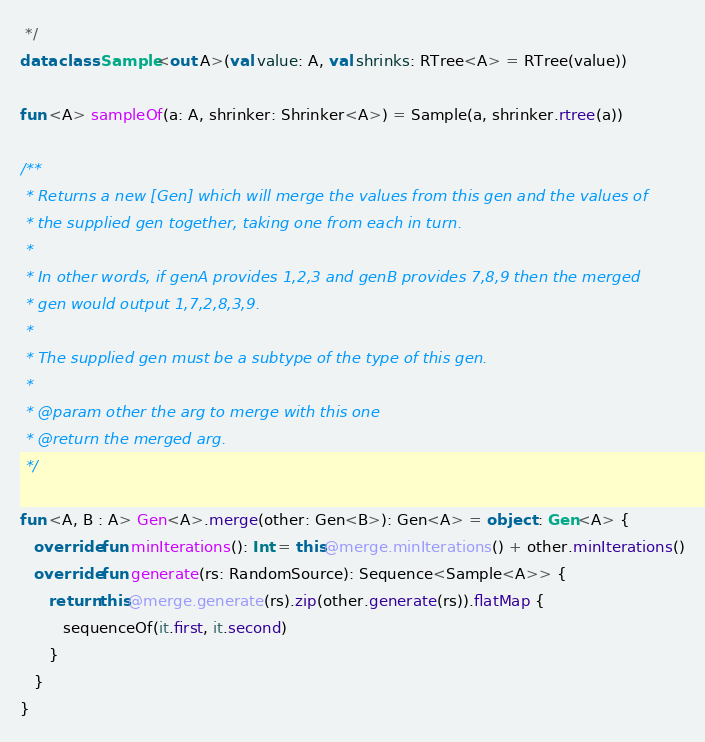<code> <loc_0><loc_0><loc_500><loc_500><_Kotlin_> */
data class Sample<out A>(val value: A, val shrinks: RTree<A> = RTree(value))

fun <A> sampleOf(a: A, shrinker: Shrinker<A>) = Sample(a, shrinker.rtree(a))

/**
 * Returns a new [Gen] which will merge the values from this gen and the values of
 * the supplied gen together, taking one from each in turn.
 *
 * In other words, if genA provides 1,2,3 and genB provides 7,8,9 then the merged
 * gen would output 1,7,2,8,3,9.
 *
 * The supplied gen must be a subtype of the type of this gen.
 *
 * @param other the arg to merge with this one
 * @return the merged arg.
 */

fun <A, B : A> Gen<A>.merge(other: Gen<B>): Gen<A> = object : Gen<A> {
   override fun minIterations(): Int = this@merge.minIterations() + other.minIterations()
   override fun generate(rs: RandomSource): Sequence<Sample<A>> {
      return this@merge.generate(rs).zip(other.generate(rs)).flatMap {
         sequenceOf(it.first, it.second)
      }
   }
}
</code> 